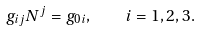Convert formula to latex. <formula><loc_0><loc_0><loc_500><loc_500>g _ { i j } N ^ { j } = g _ { 0 i } , \quad i = 1 , 2 , 3 .</formula> 